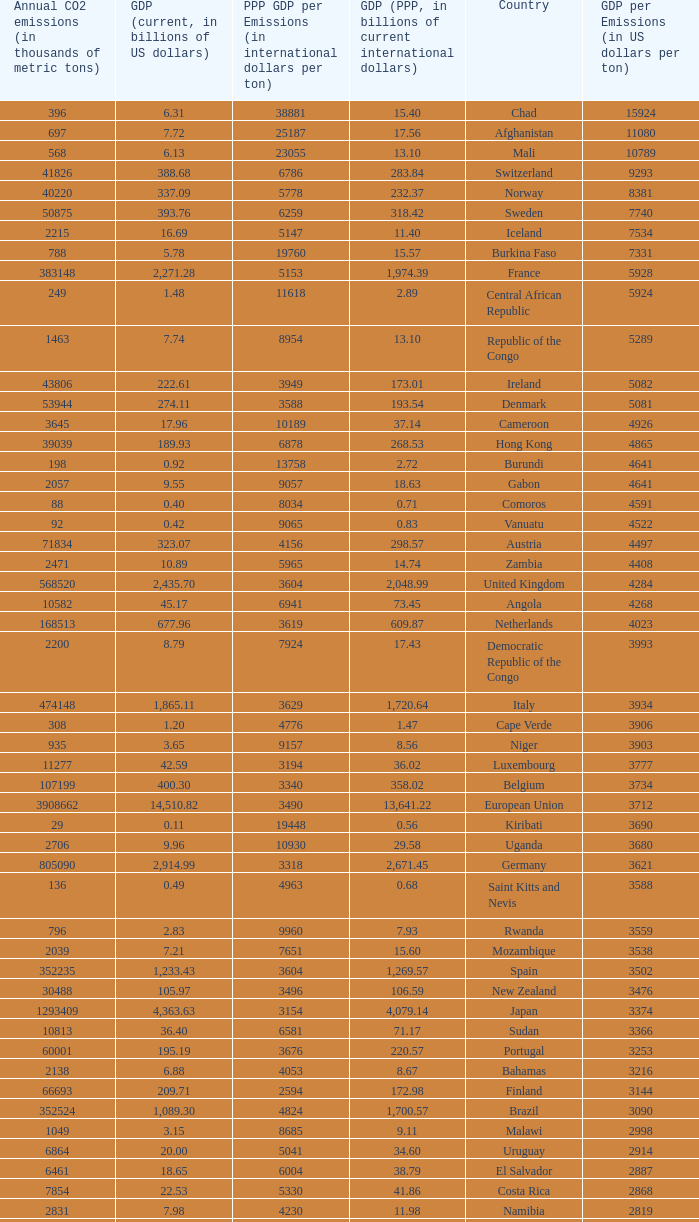When the gdp (ppp, in billions of current international dollars) is 7.93, what is the maximum ppp gdp per emissions (in international dollars per ton)? 9960.0. Would you mind parsing the complete table? {'header': ['Annual CO2 emissions (in thousands of metric tons)', 'GDP (current, in billions of US dollars)', 'PPP GDP per Emissions (in international dollars per ton)', 'GDP (PPP, in billions of current international dollars)', 'Country', 'GDP per Emissions (in US dollars per ton)'], 'rows': [['396', '6.31', '38881', '15.40', 'Chad', '15924'], ['697', '7.72', '25187', '17.56', 'Afghanistan', '11080'], ['568', '6.13', '23055', '13.10', 'Mali', '10789'], ['41826', '388.68', '6786', '283.84', 'Switzerland', '9293'], ['40220', '337.09', '5778', '232.37', 'Norway', '8381'], ['50875', '393.76', '6259', '318.42', 'Sweden', '7740'], ['2215', '16.69', '5147', '11.40', 'Iceland', '7534'], ['788', '5.78', '19760', '15.57', 'Burkina Faso', '7331'], ['383148', '2,271.28', '5153', '1,974.39', 'France', '5928'], ['249', '1.48', '11618', '2.89', 'Central African Republic', '5924'], ['1463', '7.74', '8954', '13.10', 'Republic of the Congo', '5289'], ['43806', '222.61', '3949', '173.01', 'Ireland', '5082'], ['53944', '274.11', '3588', '193.54', 'Denmark', '5081'], ['3645', '17.96', '10189', '37.14', 'Cameroon', '4926'], ['39039', '189.93', '6878', '268.53', 'Hong Kong', '4865'], ['198', '0.92', '13758', '2.72', 'Burundi', '4641'], ['2057', '9.55', '9057', '18.63', 'Gabon', '4641'], ['88', '0.40', '8034', '0.71', 'Comoros', '4591'], ['92', '0.42', '9065', '0.83', 'Vanuatu', '4522'], ['71834', '323.07', '4156', '298.57', 'Austria', '4497'], ['2471', '10.89', '5965', '14.74', 'Zambia', '4408'], ['568520', '2,435.70', '3604', '2,048.99', 'United Kingdom', '4284'], ['10582', '45.17', '6941', '73.45', 'Angola', '4268'], ['168513', '677.96', '3619', '609.87', 'Netherlands', '4023'], ['2200', '8.79', '7924', '17.43', 'Democratic Republic of the Congo', '3993'], ['474148', '1,865.11', '3629', '1,720.64', 'Italy', '3934'], ['308', '1.20', '4776', '1.47', 'Cape Verde', '3906'], ['935', '3.65', '9157', '8.56', 'Niger', '3903'], ['11277', '42.59', '3194', '36.02', 'Luxembourg', '3777'], ['107199', '400.30', '3340', '358.02', 'Belgium', '3734'], ['3908662', '14,510.82', '3490', '13,641.22', 'European Union', '3712'], ['29', '0.11', '19448', '0.56', 'Kiribati', '3690'], ['2706', '9.96', '10930', '29.58', 'Uganda', '3680'], ['805090', '2,914.99', '3318', '2,671.45', 'Germany', '3621'], ['136', '0.49', '4963', '0.68', 'Saint Kitts and Nevis', '3588'], ['796', '2.83', '9960', '7.93', 'Rwanda', '3559'], ['2039', '7.21', '7651', '15.60', 'Mozambique', '3538'], ['352235', '1,233.43', '3604', '1,269.57', 'Spain', '3502'], ['30488', '105.97', '3496', '106.59', 'New Zealand', '3476'], ['1293409', '4,363.63', '3154', '4,079.14', 'Japan', '3374'], ['10813', '36.40', '6581', '71.17', 'Sudan', '3366'], ['60001', '195.19', '3676', '220.57', 'Portugal', '3253'], ['2138', '6.88', '4053', '8.67', 'Bahamas', '3216'], ['66693', '209.71', '2594', '172.98', 'Finland', '3144'], ['352524', '1,089.30', '4824', '1,700.57', 'Brazil', '3090'], ['1049', '3.15', '8685', '9.11', 'Malawi', '2998'], ['6864', '20.00', '5041', '34.60', 'Uruguay', '2914'], ['6461', '18.65', '6004', '38.79', 'El Salvador', '2887'], ['7854', '22.53', '5330', '41.86', 'Costa Rica', '2868'], ['2831', '7.98', '4230', '11.98', 'Namibia', '2819'], ['3241', '9.03', '8595', '27.86', 'Nepal', '2787'], ['96382', '267.71', '3150', '303.60', 'Greece', '2778'], ['158', '0.43', '5987', '0.95', 'Samoa', '2747'], ['117', '0.32', '5632', '0.66', 'Dominica', '2709'], ['7462', '19.94', '4720', '35.22', 'Latvia', '2672'], ['5372', '14.35', '8276', '44.46', 'Tanzania', '2671'], ['1811', '4.84', '5809', '10.52', 'Haiti', '2670'], ['6428', '17.13', '4700', '30.21', 'Panama', '2666'], ['1016', '2.67', '5095', '5.18', 'Swaziland', '2629'], ['11766', '30.26', '4910', '57.77', 'Guatemala', '2572'], ['15173', '38.94', '3370', '51.14', 'Slovenia', '2566'], ['63422', '162.50', '5405', '342.77', 'Colombia', '2562'], ['2548', '6.44', '3485', '8.88', 'Malta', '2528'], ['6882', '17.38', '4536', '31.22', 'Ivory Coast', '2526'], ['6006', '15.17', '9055', '54.39', 'Ethiopia', '2525'], ['367', '0.93', '4616', '1.69', 'Saint Lucia', '2520'], ['198', '0.50', '4843', '0.96', 'Saint Vincent and the Grenadines', '2515'], ['56217', '139.18', '3713', '208.75', 'Singapore', '2476'], ['1426', '3.51', '8000', '11.41', 'Laos', '2459'], ['381', '0.93', '6850', '2.61', 'Bhutan', '2444'], ['60100', '146.76', '3568', '214.41', 'Chile', '2442'], ['38643', '92.31', '5072', '195.99', 'Peru', '2389'], ['1338', '3.19', '3590', '4.80', 'Barbados', '2385'], ['11876', '28.28', '6526', '77.51', 'Sri Lanka', '2381'], ['4770', '11.30', '4929', '23.51', 'Botswana', '2369'], ['425', '1.01', '3315', '1.41', 'Antigua and Barbuda', '2367'], ['7788', '18.43', '2566', '19.99', 'Cyprus', '2366'], ['544680', '1,278.97', '2210', '1,203.74', 'Canada', '2348'], ['242', '0.56', '4331', '1.05', 'Grenada', '2331'], ['3986', '9.28', '6224', '24.81', 'Paraguay', '2327'], ['5752289', '13,178.35', '2291', '13,178.35', 'United States', '2291'], ['4356', '9.60', '3618', '15.76', 'Equatorial Guinea', '2205'], ['4261', '9.37', '4529', '19.30', 'Senegal', '2198'], ['554', '1.21', '6283', '3.48', 'Eritrea', '2186'], ['436150', '952.34', '3230', '1,408.81', 'Mexico', '2184'], ['1360', '2.90', '6829', '9.29', 'Guinea', '2135'], ['14190', '30.08', '3808', '54.04', 'Lithuania', '2120'], ['4301', '9.11', '4264', '18.34', 'Albania', '2119'], ['23683', '49.04', '3067', '72.63', 'Croatia', '2071'], ['70440', '143.98', '2479', '174.61', 'Israel', '2044'], ['372013', '755.21', '1919', '713.96', 'Australia', '2030'], ['475248', '952.03', '2505', '1,190.70', 'South Korea', '2003'], ['1610', '3.17', '2320', '3.74', 'Fiji', '1967'], ['269452', '529.19', '3060', '824.58', 'Turkey', '1964'], ['57644', '113.05', '3189', '183.84', 'Hungary', '1961'], ['2834', '5.52', '5943', '16.84', 'Madagascar', '1947'], ['5911', '11.47', '3203', '18.93', 'Brunei', '1940'], ['176', '0.33', '11153', '1.96', 'Timor-Leste', '1858'], ['180', '0.33', '4789', '0.86', 'Solomon Islands', '1856'], ['12151', '22.52', '4340', '52.74', 'Kenya', '1853'], ['1221', '2.22', '4066', '4.96', 'Togo', '1818'], ['132', '0.24', '4076', '0.54', 'Tonga', '1788'], ['4074', '7.26', '5653', '23.03', 'Cambodia', '1783'], ['20357', '35.28', '3141', '63.94', 'Dominican Republic', '1733'], ['68328', '117.57', '3984', '272.25', 'Philippines', '1721'], ['6973', '11.53', '5359', '37.37', 'Bolivia', '1653'], ['3850', '6.32', '3399', '13.09', 'Mauritius', '1641'], ['1665', '2.70', '3448', '5.74', 'Mauritania', '1621'], ['488', '0.77', '3297', '1.61', 'Djibouti', '1576'], ['41609', '65.20', '4589', '190.93', 'Bangladesh', '1567'], ['3109', '4.74', '3631', '11.29', 'Benin', '1524'], ['334', '0.51', '5743', '1.92', 'Gambia', '1521'], ['97262', '146.89', '2758', '268.21', 'Nigeria', '1510'], ['7194', '10.84', '3920', '28.20', 'Honduras', '1507'], ['37459', '56.00', '2583', '96.76', 'Slovakia', '1495'], ['818', '1.21', '2823', '2.31', 'Belize', '1483'], ['15330', '22.44', '2639', '40.46', 'Lebanon', '1464'], ['4371', '6.38', '3357', '14.68', 'Armenia', '1461'], ['45316', '65.64', '2655', '120.32', 'Morocco', '1448'], ['10025', '14.50', '5541', '55.55', 'Burma', '1447'], ['994', '1.42', '3644', '3.62', 'Sierra Leone', '1433'], ['5518', '7.77', '3221', '17.77', 'Georgia', '1408'], ['9240', '12.73', '3108', '28.72', 'Ghana', '1378'], ['23126', '31.11', '3052', '70.57', 'Tunisia', '1345'], ['31328', '41.40', '3016', '94.48', 'Ecuador', '1322'], ['744', '0.97', '2157', '1.61', 'Seychelles', '1301'], ['98490', '122.70', '2300', '226.51', 'Romania', '1246'], ['46193', '56.92', '1448', '66.90', 'Qatar', '1232'], ['173536', '212.71', '2707', '469.75', 'Argentina', '1226'], ['116991', '142.31', '1953', '228.48', 'Czech Republic', '1216'], ['4334', '5.26', '3444', '14.93', 'Nicaragua', '1215'], ['103', '0.13', '2311', '0.24', 'São Tomé and Príncipe', '1214'], ['4620', '5.61', '2361', '10.91', 'Papua New Guinea', '1213'], ['139553', '164.17', '1106', '154.35', 'United Arab Emirates', '1176'], ['86599', '101.56', '1385', '119.96', 'Kuwait', '1173'], ['279', '0.32', '2724', '0.76', 'Guinea-Bissau', '1136'], ['333483', '364.35', '2303', '767.92', 'Indonesia', '1093'], ['171593', '184.25', '1753', '300.80', 'Venezuela', '1074'], ['318219', '341.67', '1785', '567.94', 'Poland', '1074'], ['869', '0.92', '1654', '1.44', 'Maldives', '1053'], ['55495', '55.08', '1360', '75.47', 'Libya', '992'], ['12151', '11.45', '1640', '19.93', 'Jamaica', '942'], ['17523', '16.45', '1444', '25.31', 'Estonia', '939'], ['381564', '356.63', '1368', '522.12', 'Saudi Arabia', '935'], ['21201', '19.06', '2321', '49.21', 'Yemen', '899'], ['142659', '127.49', '2614', '372.96', 'Pakistan', '894'], ['132715', '116.83', '1578', '209.40', 'Algeria', '880'], ['2438', '2.14', '1543', '3.76', 'Suriname', '878'], ['41378', '35.73', '1364', '56.44', 'Oman', '863'], ['187865', '156.86', '1751', '328.97', 'Malaysia', '835'], ['785', '0.61', '1520', '1.19', 'Liberia', '780'], ['272521', '206.99', '1774', '483.56', 'Thailand', '760'], ['21292', '15.85', '1053', '22.41', 'Bahrain', '744'], ['20724', '14.84', '1266', '26.25', 'Jordan', '716'], ['48085', '31.69', '1648', '79.24', 'Bulgaria', '659'], ['166800', '107.38', '2204', '367.64', 'Egypt', '644'], ['1564669', '989.43', '1206', '1,887.61', 'Russia', '632'], ['414649', '257.89', '1045', '433.51', 'South Africa', '622'], ['53266', '32.30', '1369', '72.93', 'Serbia and Montenegro', '606'], ['1507', '0.91', '1792', '2.70', 'Guyana', '606'], ['35050', '21.03', '1475', '51.71', 'Azerbaijan', '600'], ['10875', '6.38', '1484', '16.14', 'Macedonia', '587'], ['1510351', '874.77', '1770', '2,672.66', 'India', '579'], ['33601', '19.38', '703', '23.62', 'Trinidad and Tobago', '577'], ['106132', '60.93', '1874', '198.94', 'Vietnam', '574'], ['68849', '36.96', '1377', '94.80', 'Belarus', '537'], ['92572', '49.27', '978', '90.51', 'Iraq', '532'], ['5566', '2.84', '1698', '9.45', 'Kyrgyzstan', '510'], ['11081', '5.60', '207', '2.29', 'Zimbabwe', '505'], ['68460', '33.51', '1199', '82.09', 'Syria', '489'], ['44103', '21.40', '531', '23.40', 'Turkmenistan', '485'], ['466976', '222.13', '1485', '693.32', 'Iran', '476'], ['27438', '12.28', '937', '25.70', 'Bosnia and Herzegovina', '447'], ['6391', '2.81', '1672', '10.69', 'Tajikistan', '440'], ['7821', '3.41', '1175', '9.19', 'Moldova', '436'], ['6103493', '2,657.84', '1003', '6,122.24', 'China', '435'], ['193508', '81.00', '778', '150.56', 'Kazakhstan', '419'], ['319158', '108.00', '913', '291.30', 'Ukraine', '338'], ['9442', '3.16', '791', '7.47', 'Mongolia', '334']]} 